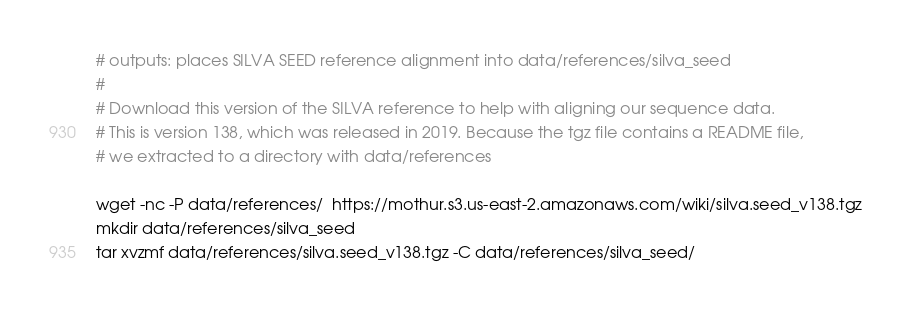<code> <loc_0><loc_0><loc_500><loc_500><_Bash_># outputs: places SILVA SEED reference alignment into data/references/silva_seed
#
# Download this version of the SILVA reference to help with aligning our sequence data.
# This is version 138, which was released in 2019. Because the tgz file contains a README file,
# we extracted to a directory with data/references

wget -nc -P data/references/  https://mothur.s3.us-east-2.amazonaws.com/wiki/silva.seed_v138.tgz
mkdir data/references/silva_seed
tar xvzmf data/references/silva.seed_v138.tgz -C data/references/silva_seed/
</code> 